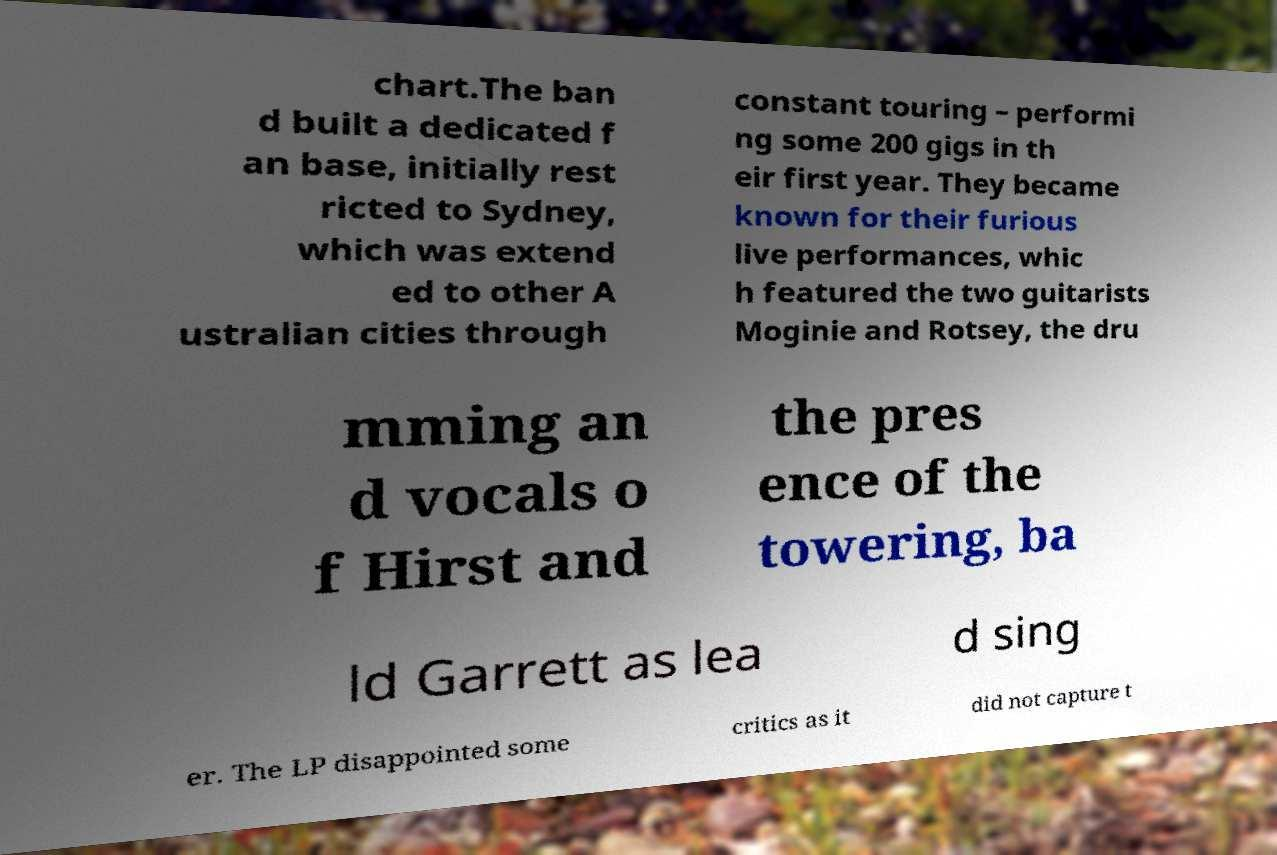For documentation purposes, I need the text within this image transcribed. Could you provide that? chart.The ban d built a dedicated f an base, initially rest ricted to Sydney, which was extend ed to other A ustralian cities through constant touring – performi ng some 200 gigs in th eir first year. They became known for their furious live performances, whic h featured the two guitarists Moginie and Rotsey, the dru mming an d vocals o f Hirst and the pres ence of the towering, ba ld Garrett as lea d sing er. The LP disappointed some critics as it did not capture t 